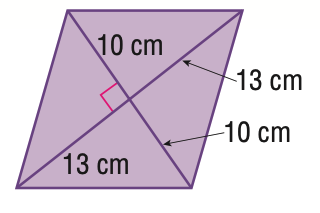Question: Find the area of the quadrilateral.
Choices:
A. 130
B. 230
C. 260
D. 520
Answer with the letter. Answer: C 